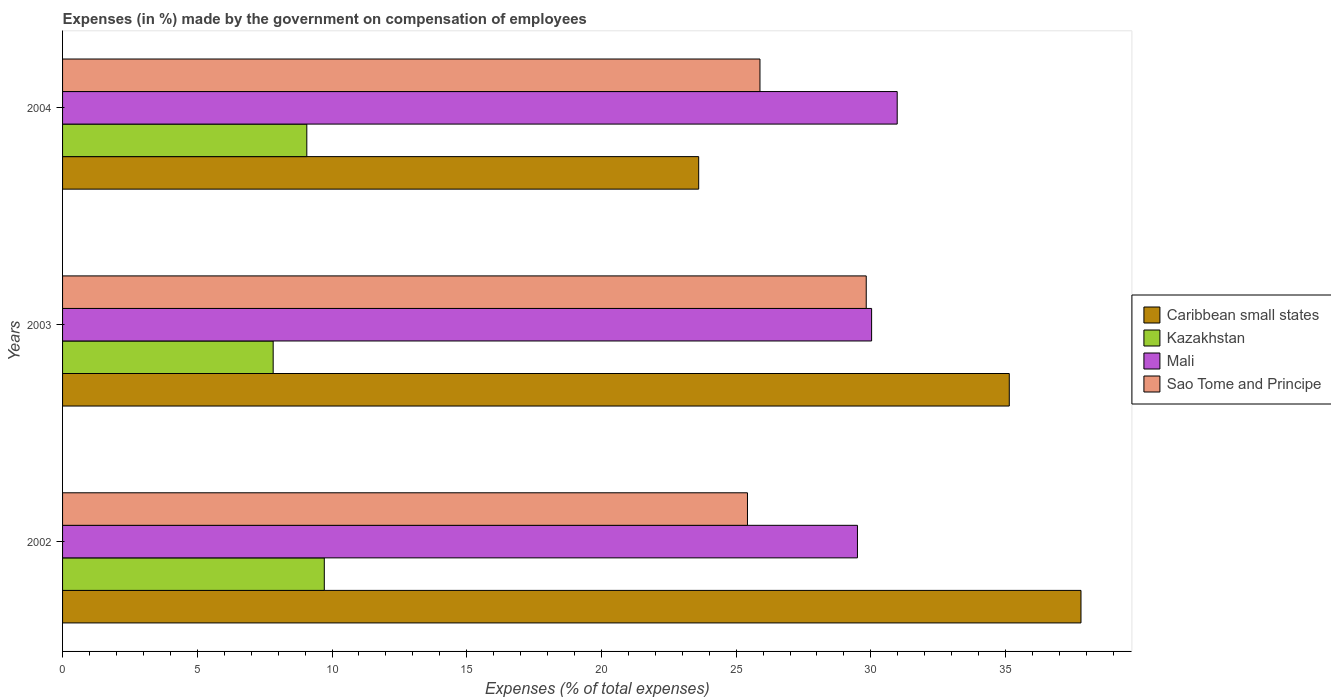How many groups of bars are there?
Your answer should be compact. 3. Are the number of bars per tick equal to the number of legend labels?
Provide a succinct answer. Yes. How many bars are there on the 2nd tick from the top?
Keep it short and to the point. 4. How many bars are there on the 1st tick from the bottom?
Keep it short and to the point. 4. What is the percentage of expenses made by the government on compensation of employees in Kazakhstan in 2003?
Make the answer very short. 7.82. Across all years, what is the maximum percentage of expenses made by the government on compensation of employees in Mali?
Keep it short and to the point. 30.98. Across all years, what is the minimum percentage of expenses made by the government on compensation of employees in Sao Tome and Principe?
Give a very brief answer. 25.42. In which year was the percentage of expenses made by the government on compensation of employees in Caribbean small states maximum?
Offer a very short reply. 2002. What is the total percentage of expenses made by the government on compensation of employees in Mali in the graph?
Give a very brief answer. 90.51. What is the difference between the percentage of expenses made by the government on compensation of employees in Kazakhstan in 2002 and that in 2003?
Keep it short and to the point. 1.9. What is the difference between the percentage of expenses made by the government on compensation of employees in Kazakhstan in 2004 and the percentage of expenses made by the government on compensation of employees in Sao Tome and Principe in 2003?
Make the answer very short. -20.76. What is the average percentage of expenses made by the government on compensation of employees in Caribbean small states per year?
Keep it short and to the point. 32.18. In the year 2003, what is the difference between the percentage of expenses made by the government on compensation of employees in Mali and percentage of expenses made by the government on compensation of employees in Kazakhstan?
Provide a short and direct response. 22.21. What is the ratio of the percentage of expenses made by the government on compensation of employees in Kazakhstan in 2003 to that in 2004?
Make the answer very short. 0.86. Is the percentage of expenses made by the government on compensation of employees in Sao Tome and Principe in 2002 less than that in 2003?
Give a very brief answer. Yes. Is the difference between the percentage of expenses made by the government on compensation of employees in Mali in 2003 and 2004 greater than the difference between the percentage of expenses made by the government on compensation of employees in Kazakhstan in 2003 and 2004?
Provide a succinct answer. Yes. What is the difference between the highest and the second highest percentage of expenses made by the government on compensation of employees in Mali?
Provide a succinct answer. 0.95. What is the difference between the highest and the lowest percentage of expenses made by the government on compensation of employees in Kazakhstan?
Provide a succinct answer. 1.9. What does the 2nd bar from the top in 2004 represents?
Offer a terse response. Mali. What does the 3rd bar from the bottom in 2004 represents?
Provide a short and direct response. Mali. Is it the case that in every year, the sum of the percentage of expenses made by the government on compensation of employees in Mali and percentage of expenses made by the government on compensation of employees in Kazakhstan is greater than the percentage of expenses made by the government on compensation of employees in Sao Tome and Principe?
Offer a very short reply. Yes. How many bars are there?
Make the answer very short. 12. Are all the bars in the graph horizontal?
Your response must be concise. Yes. How many years are there in the graph?
Offer a terse response. 3. Does the graph contain grids?
Offer a very short reply. No. How many legend labels are there?
Offer a very short reply. 4. How are the legend labels stacked?
Your answer should be compact. Vertical. What is the title of the graph?
Ensure brevity in your answer.  Expenses (in %) made by the government on compensation of employees. Does "Brazil" appear as one of the legend labels in the graph?
Offer a terse response. No. What is the label or title of the X-axis?
Make the answer very short. Expenses (% of total expenses). What is the label or title of the Y-axis?
Your answer should be compact. Years. What is the Expenses (% of total expenses) in Caribbean small states in 2002?
Offer a terse response. 37.8. What is the Expenses (% of total expenses) of Kazakhstan in 2002?
Your response must be concise. 9.71. What is the Expenses (% of total expenses) in Mali in 2002?
Ensure brevity in your answer.  29.5. What is the Expenses (% of total expenses) in Sao Tome and Principe in 2002?
Make the answer very short. 25.42. What is the Expenses (% of total expenses) in Caribbean small states in 2003?
Provide a short and direct response. 35.14. What is the Expenses (% of total expenses) of Kazakhstan in 2003?
Keep it short and to the point. 7.82. What is the Expenses (% of total expenses) in Mali in 2003?
Provide a succinct answer. 30.03. What is the Expenses (% of total expenses) of Sao Tome and Principe in 2003?
Offer a terse response. 29.83. What is the Expenses (% of total expenses) of Caribbean small states in 2004?
Offer a terse response. 23.61. What is the Expenses (% of total expenses) of Kazakhstan in 2004?
Offer a terse response. 9.07. What is the Expenses (% of total expenses) in Mali in 2004?
Ensure brevity in your answer.  30.98. What is the Expenses (% of total expenses) in Sao Tome and Principe in 2004?
Give a very brief answer. 25.88. Across all years, what is the maximum Expenses (% of total expenses) of Caribbean small states?
Offer a terse response. 37.8. Across all years, what is the maximum Expenses (% of total expenses) of Kazakhstan?
Your answer should be very brief. 9.71. Across all years, what is the maximum Expenses (% of total expenses) in Mali?
Give a very brief answer. 30.98. Across all years, what is the maximum Expenses (% of total expenses) of Sao Tome and Principe?
Ensure brevity in your answer.  29.83. Across all years, what is the minimum Expenses (% of total expenses) in Caribbean small states?
Offer a terse response. 23.61. Across all years, what is the minimum Expenses (% of total expenses) in Kazakhstan?
Offer a terse response. 7.82. Across all years, what is the minimum Expenses (% of total expenses) in Mali?
Provide a short and direct response. 29.5. Across all years, what is the minimum Expenses (% of total expenses) of Sao Tome and Principe?
Offer a terse response. 25.42. What is the total Expenses (% of total expenses) in Caribbean small states in the graph?
Ensure brevity in your answer.  96.54. What is the total Expenses (% of total expenses) in Kazakhstan in the graph?
Provide a succinct answer. 26.6. What is the total Expenses (% of total expenses) in Mali in the graph?
Make the answer very short. 90.51. What is the total Expenses (% of total expenses) of Sao Tome and Principe in the graph?
Provide a short and direct response. 81.13. What is the difference between the Expenses (% of total expenses) of Caribbean small states in 2002 and that in 2003?
Give a very brief answer. 2.66. What is the difference between the Expenses (% of total expenses) in Kazakhstan in 2002 and that in 2003?
Provide a short and direct response. 1.9. What is the difference between the Expenses (% of total expenses) in Mali in 2002 and that in 2003?
Give a very brief answer. -0.53. What is the difference between the Expenses (% of total expenses) of Sao Tome and Principe in 2002 and that in 2003?
Offer a terse response. -4.41. What is the difference between the Expenses (% of total expenses) of Caribbean small states in 2002 and that in 2004?
Give a very brief answer. 14.19. What is the difference between the Expenses (% of total expenses) of Kazakhstan in 2002 and that in 2004?
Your response must be concise. 0.65. What is the difference between the Expenses (% of total expenses) in Mali in 2002 and that in 2004?
Your answer should be very brief. -1.48. What is the difference between the Expenses (% of total expenses) in Sao Tome and Principe in 2002 and that in 2004?
Offer a terse response. -0.46. What is the difference between the Expenses (% of total expenses) of Caribbean small states in 2003 and that in 2004?
Your response must be concise. 11.53. What is the difference between the Expenses (% of total expenses) of Kazakhstan in 2003 and that in 2004?
Your answer should be very brief. -1.25. What is the difference between the Expenses (% of total expenses) of Mali in 2003 and that in 2004?
Provide a succinct answer. -0.95. What is the difference between the Expenses (% of total expenses) of Sao Tome and Principe in 2003 and that in 2004?
Your response must be concise. 3.94. What is the difference between the Expenses (% of total expenses) in Caribbean small states in 2002 and the Expenses (% of total expenses) in Kazakhstan in 2003?
Your answer should be compact. 29.98. What is the difference between the Expenses (% of total expenses) in Caribbean small states in 2002 and the Expenses (% of total expenses) in Mali in 2003?
Provide a succinct answer. 7.77. What is the difference between the Expenses (% of total expenses) of Caribbean small states in 2002 and the Expenses (% of total expenses) of Sao Tome and Principe in 2003?
Ensure brevity in your answer.  7.97. What is the difference between the Expenses (% of total expenses) in Kazakhstan in 2002 and the Expenses (% of total expenses) in Mali in 2003?
Make the answer very short. -20.31. What is the difference between the Expenses (% of total expenses) of Kazakhstan in 2002 and the Expenses (% of total expenses) of Sao Tome and Principe in 2003?
Your answer should be very brief. -20.11. What is the difference between the Expenses (% of total expenses) of Mali in 2002 and the Expenses (% of total expenses) of Sao Tome and Principe in 2003?
Make the answer very short. -0.33. What is the difference between the Expenses (% of total expenses) in Caribbean small states in 2002 and the Expenses (% of total expenses) in Kazakhstan in 2004?
Offer a very short reply. 28.73. What is the difference between the Expenses (% of total expenses) of Caribbean small states in 2002 and the Expenses (% of total expenses) of Mali in 2004?
Provide a succinct answer. 6.82. What is the difference between the Expenses (% of total expenses) in Caribbean small states in 2002 and the Expenses (% of total expenses) in Sao Tome and Principe in 2004?
Give a very brief answer. 11.91. What is the difference between the Expenses (% of total expenses) of Kazakhstan in 2002 and the Expenses (% of total expenses) of Mali in 2004?
Offer a very short reply. -21.26. What is the difference between the Expenses (% of total expenses) in Kazakhstan in 2002 and the Expenses (% of total expenses) in Sao Tome and Principe in 2004?
Your answer should be very brief. -16.17. What is the difference between the Expenses (% of total expenses) of Mali in 2002 and the Expenses (% of total expenses) of Sao Tome and Principe in 2004?
Provide a short and direct response. 3.62. What is the difference between the Expenses (% of total expenses) of Caribbean small states in 2003 and the Expenses (% of total expenses) of Kazakhstan in 2004?
Offer a very short reply. 26.07. What is the difference between the Expenses (% of total expenses) in Caribbean small states in 2003 and the Expenses (% of total expenses) in Mali in 2004?
Ensure brevity in your answer.  4.16. What is the difference between the Expenses (% of total expenses) in Caribbean small states in 2003 and the Expenses (% of total expenses) in Sao Tome and Principe in 2004?
Provide a succinct answer. 9.25. What is the difference between the Expenses (% of total expenses) of Kazakhstan in 2003 and the Expenses (% of total expenses) of Mali in 2004?
Provide a short and direct response. -23.16. What is the difference between the Expenses (% of total expenses) in Kazakhstan in 2003 and the Expenses (% of total expenses) in Sao Tome and Principe in 2004?
Give a very brief answer. -18.07. What is the difference between the Expenses (% of total expenses) in Mali in 2003 and the Expenses (% of total expenses) in Sao Tome and Principe in 2004?
Keep it short and to the point. 4.14. What is the average Expenses (% of total expenses) in Caribbean small states per year?
Your answer should be compact. 32.18. What is the average Expenses (% of total expenses) of Kazakhstan per year?
Keep it short and to the point. 8.87. What is the average Expenses (% of total expenses) in Mali per year?
Make the answer very short. 30.17. What is the average Expenses (% of total expenses) of Sao Tome and Principe per year?
Offer a terse response. 27.04. In the year 2002, what is the difference between the Expenses (% of total expenses) in Caribbean small states and Expenses (% of total expenses) in Kazakhstan?
Offer a terse response. 28.08. In the year 2002, what is the difference between the Expenses (% of total expenses) of Caribbean small states and Expenses (% of total expenses) of Mali?
Keep it short and to the point. 8.3. In the year 2002, what is the difference between the Expenses (% of total expenses) in Caribbean small states and Expenses (% of total expenses) in Sao Tome and Principe?
Keep it short and to the point. 12.38. In the year 2002, what is the difference between the Expenses (% of total expenses) in Kazakhstan and Expenses (% of total expenses) in Mali?
Keep it short and to the point. -19.79. In the year 2002, what is the difference between the Expenses (% of total expenses) in Kazakhstan and Expenses (% of total expenses) in Sao Tome and Principe?
Provide a succinct answer. -15.71. In the year 2002, what is the difference between the Expenses (% of total expenses) of Mali and Expenses (% of total expenses) of Sao Tome and Principe?
Give a very brief answer. 4.08. In the year 2003, what is the difference between the Expenses (% of total expenses) of Caribbean small states and Expenses (% of total expenses) of Kazakhstan?
Give a very brief answer. 27.32. In the year 2003, what is the difference between the Expenses (% of total expenses) in Caribbean small states and Expenses (% of total expenses) in Mali?
Provide a short and direct response. 5.11. In the year 2003, what is the difference between the Expenses (% of total expenses) of Caribbean small states and Expenses (% of total expenses) of Sao Tome and Principe?
Provide a succinct answer. 5.31. In the year 2003, what is the difference between the Expenses (% of total expenses) of Kazakhstan and Expenses (% of total expenses) of Mali?
Your answer should be compact. -22.21. In the year 2003, what is the difference between the Expenses (% of total expenses) of Kazakhstan and Expenses (% of total expenses) of Sao Tome and Principe?
Make the answer very short. -22.01. In the year 2003, what is the difference between the Expenses (% of total expenses) of Mali and Expenses (% of total expenses) of Sao Tome and Principe?
Give a very brief answer. 0.2. In the year 2004, what is the difference between the Expenses (% of total expenses) in Caribbean small states and Expenses (% of total expenses) in Kazakhstan?
Ensure brevity in your answer.  14.54. In the year 2004, what is the difference between the Expenses (% of total expenses) of Caribbean small states and Expenses (% of total expenses) of Mali?
Offer a terse response. -7.37. In the year 2004, what is the difference between the Expenses (% of total expenses) in Caribbean small states and Expenses (% of total expenses) in Sao Tome and Principe?
Keep it short and to the point. -2.27. In the year 2004, what is the difference between the Expenses (% of total expenses) in Kazakhstan and Expenses (% of total expenses) in Mali?
Your answer should be compact. -21.91. In the year 2004, what is the difference between the Expenses (% of total expenses) in Kazakhstan and Expenses (% of total expenses) in Sao Tome and Principe?
Offer a terse response. -16.82. In the year 2004, what is the difference between the Expenses (% of total expenses) of Mali and Expenses (% of total expenses) of Sao Tome and Principe?
Offer a very short reply. 5.09. What is the ratio of the Expenses (% of total expenses) of Caribbean small states in 2002 to that in 2003?
Provide a short and direct response. 1.08. What is the ratio of the Expenses (% of total expenses) in Kazakhstan in 2002 to that in 2003?
Offer a terse response. 1.24. What is the ratio of the Expenses (% of total expenses) of Mali in 2002 to that in 2003?
Provide a short and direct response. 0.98. What is the ratio of the Expenses (% of total expenses) in Sao Tome and Principe in 2002 to that in 2003?
Give a very brief answer. 0.85. What is the ratio of the Expenses (% of total expenses) in Caribbean small states in 2002 to that in 2004?
Offer a very short reply. 1.6. What is the ratio of the Expenses (% of total expenses) in Kazakhstan in 2002 to that in 2004?
Your answer should be compact. 1.07. What is the ratio of the Expenses (% of total expenses) in Sao Tome and Principe in 2002 to that in 2004?
Offer a terse response. 0.98. What is the ratio of the Expenses (% of total expenses) of Caribbean small states in 2003 to that in 2004?
Keep it short and to the point. 1.49. What is the ratio of the Expenses (% of total expenses) of Kazakhstan in 2003 to that in 2004?
Offer a terse response. 0.86. What is the ratio of the Expenses (% of total expenses) in Mali in 2003 to that in 2004?
Your response must be concise. 0.97. What is the ratio of the Expenses (% of total expenses) of Sao Tome and Principe in 2003 to that in 2004?
Offer a terse response. 1.15. What is the difference between the highest and the second highest Expenses (% of total expenses) of Caribbean small states?
Ensure brevity in your answer.  2.66. What is the difference between the highest and the second highest Expenses (% of total expenses) in Kazakhstan?
Your answer should be very brief. 0.65. What is the difference between the highest and the second highest Expenses (% of total expenses) of Mali?
Offer a very short reply. 0.95. What is the difference between the highest and the second highest Expenses (% of total expenses) in Sao Tome and Principe?
Make the answer very short. 3.94. What is the difference between the highest and the lowest Expenses (% of total expenses) in Caribbean small states?
Your answer should be very brief. 14.19. What is the difference between the highest and the lowest Expenses (% of total expenses) in Kazakhstan?
Make the answer very short. 1.9. What is the difference between the highest and the lowest Expenses (% of total expenses) of Mali?
Your answer should be compact. 1.48. What is the difference between the highest and the lowest Expenses (% of total expenses) in Sao Tome and Principe?
Your answer should be compact. 4.41. 